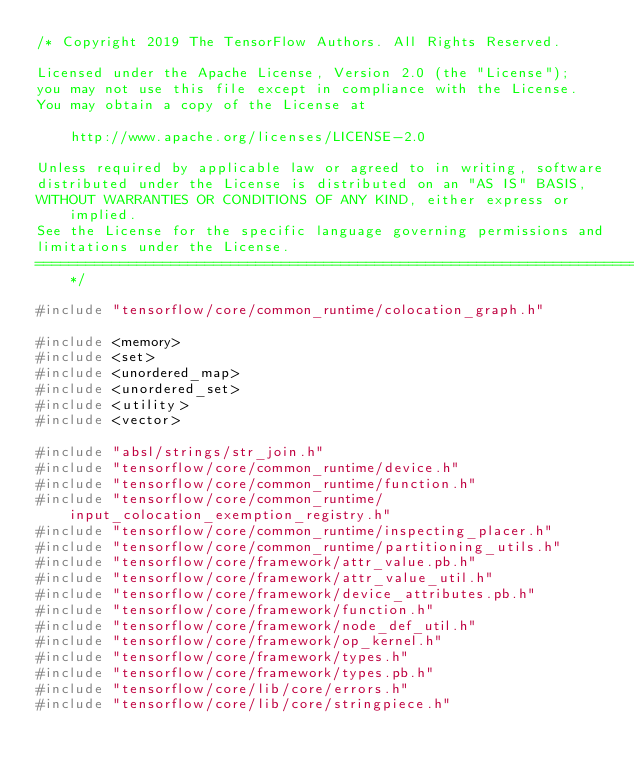<code> <loc_0><loc_0><loc_500><loc_500><_C++_>/* Copyright 2019 The TensorFlow Authors. All Rights Reserved.

Licensed under the Apache License, Version 2.0 (the "License");
you may not use this file except in compliance with the License.
You may obtain a copy of the License at

    http://www.apache.org/licenses/LICENSE-2.0

Unless required by applicable law or agreed to in writing, software
distributed under the License is distributed on an "AS IS" BASIS,
WITHOUT WARRANTIES OR CONDITIONS OF ANY KIND, either express or implied.
See the License for the specific language governing permissions and
limitations under the License.
==============================================================================*/

#include "tensorflow/core/common_runtime/colocation_graph.h"

#include <memory>
#include <set>
#include <unordered_map>
#include <unordered_set>
#include <utility>
#include <vector>

#include "absl/strings/str_join.h"
#include "tensorflow/core/common_runtime/device.h"
#include "tensorflow/core/common_runtime/function.h"
#include "tensorflow/core/common_runtime/input_colocation_exemption_registry.h"
#include "tensorflow/core/common_runtime/inspecting_placer.h"
#include "tensorflow/core/common_runtime/partitioning_utils.h"
#include "tensorflow/core/framework/attr_value.pb.h"
#include "tensorflow/core/framework/attr_value_util.h"
#include "tensorflow/core/framework/device_attributes.pb.h"
#include "tensorflow/core/framework/function.h"
#include "tensorflow/core/framework/node_def_util.h"
#include "tensorflow/core/framework/op_kernel.h"
#include "tensorflow/core/framework/types.h"
#include "tensorflow/core/framework/types.pb.h"
#include "tensorflow/core/lib/core/errors.h"
#include "tensorflow/core/lib/core/stringpiece.h"</code> 